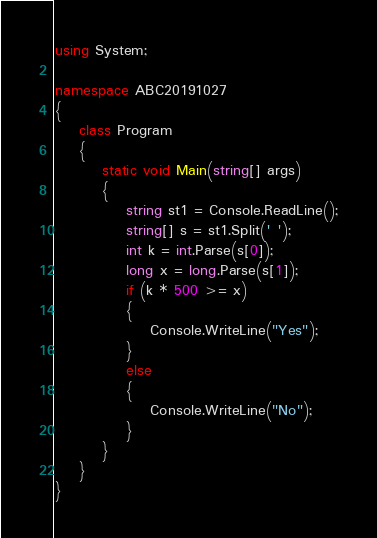Convert code to text. <code><loc_0><loc_0><loc_500><loc_500><_C#_>using System;

namespace ABC20191027
{
    class Program
    {
        static void Main(string[] args)
        {
            string st1 = Console.ReadLine();
            string[] s = st1.Split(' ');
            int k = int.Parse(s[0]);
            long x = long.Parse(s[1]);
            if (k * 500 >= x)
            {
                Console.WriteLine("Yes");
            }
            else
            {
                Console.WriteLine("No");
            }
        }
    }
}</code> 